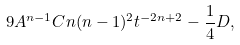Convert formula to latex. <formula><loc_0><loc_0><loc_500><loc_500>9 A ^ { n - 1 } C n ( n - 1 ) ^ { 2 } t ^ { - 2 n + 2 } - \frac { 1 } { 4 } D ,</formula> 